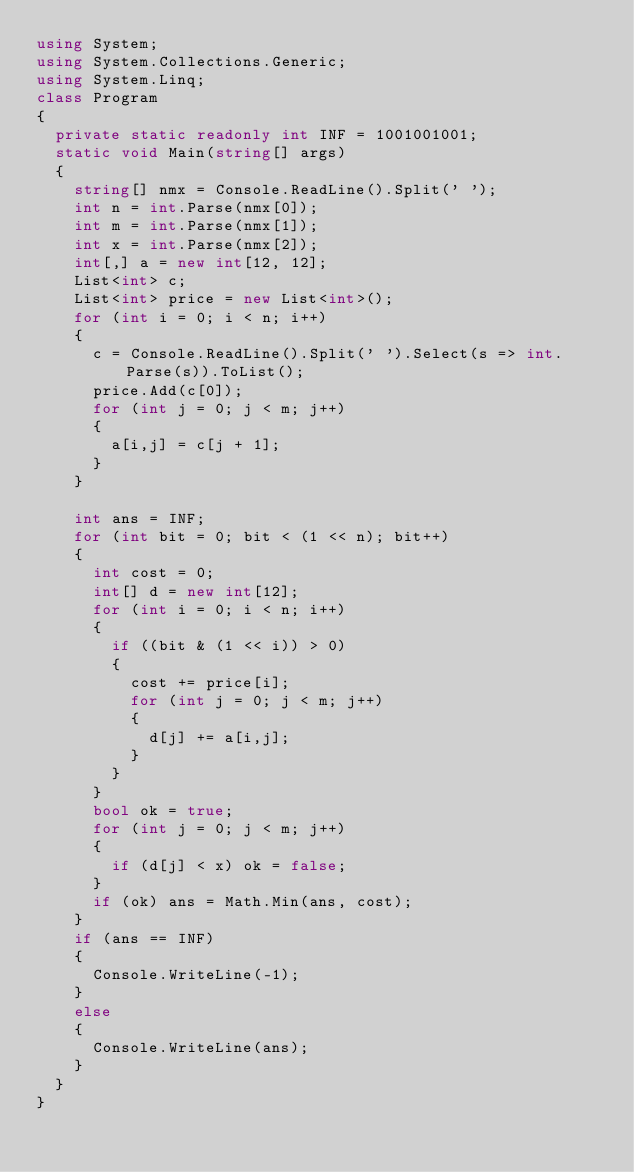Convert code to text. <code><loc_0><loc_0><loc_500><loc_500><_C#_>using System;
using System.Collections.Generic;
using System.Linq;
class Program
{
  private static readonly int INF = 1001001001;
  static void Main(string[] args)
  {
    string[] nmx = Console.ReadLine().Split(' ');
    int n = int.Parse(nmx[0]);
    int m = int.Parse(nmx[1]);
    int x = int.Parse(nmx[2]);
    int[,] a = new int[12, 12];
    List<int> c;
    List<int> price = new List<int>();
    for (int i = 0; i < n; i++)
    {
      c = Console.ReadLine().Split(' ').Select(s => int.Parse(s)).ToList();
      price.Add(c[0]);
      for (int j = 0; j < m; j++)
      {
        a[i,j] = c[j + 1];
      }
    }

    int ans = INF;
    for (int bit = 0; bit < (1 << n); bit++)
    {
      int cost = 0;
      int[] d = new int[12];
      for (int i = 0; i < n; i++)
      {
        if ((bit & (1 << i)) > 0)
        {
          cost += price[i];
          for (int j = 0; j < m; j++)
          {
            d[j] += a[i,j];
          }
        }
      }
      bool ok = true;
      for (int j = 0; j < m; j++)
      {
        if (d[j] < x) ok = false;
      }
      if (ok) ans = Math.Min(ans, cost);
    }
    if (ans == INF)
    {
      Console.WriteLine(-1);
    }
    else
    {
      Console.WriteLine(ans);
    }
  }
}</code> 